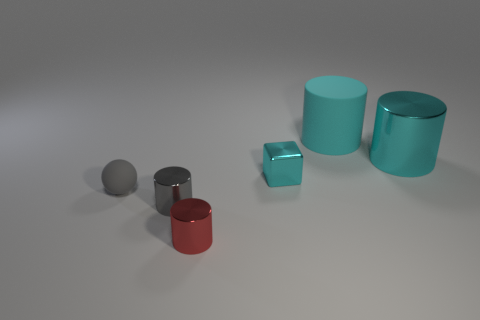What might be the purpose of arranging these objects in such a manner? This arrangement could be part of a visual composition exercise, perhaps for a study in three-dimensional rendering or a lesson in photography focusing on light, shadow, and reflections. It beautifully demonstrates how different shapes interact with light. 